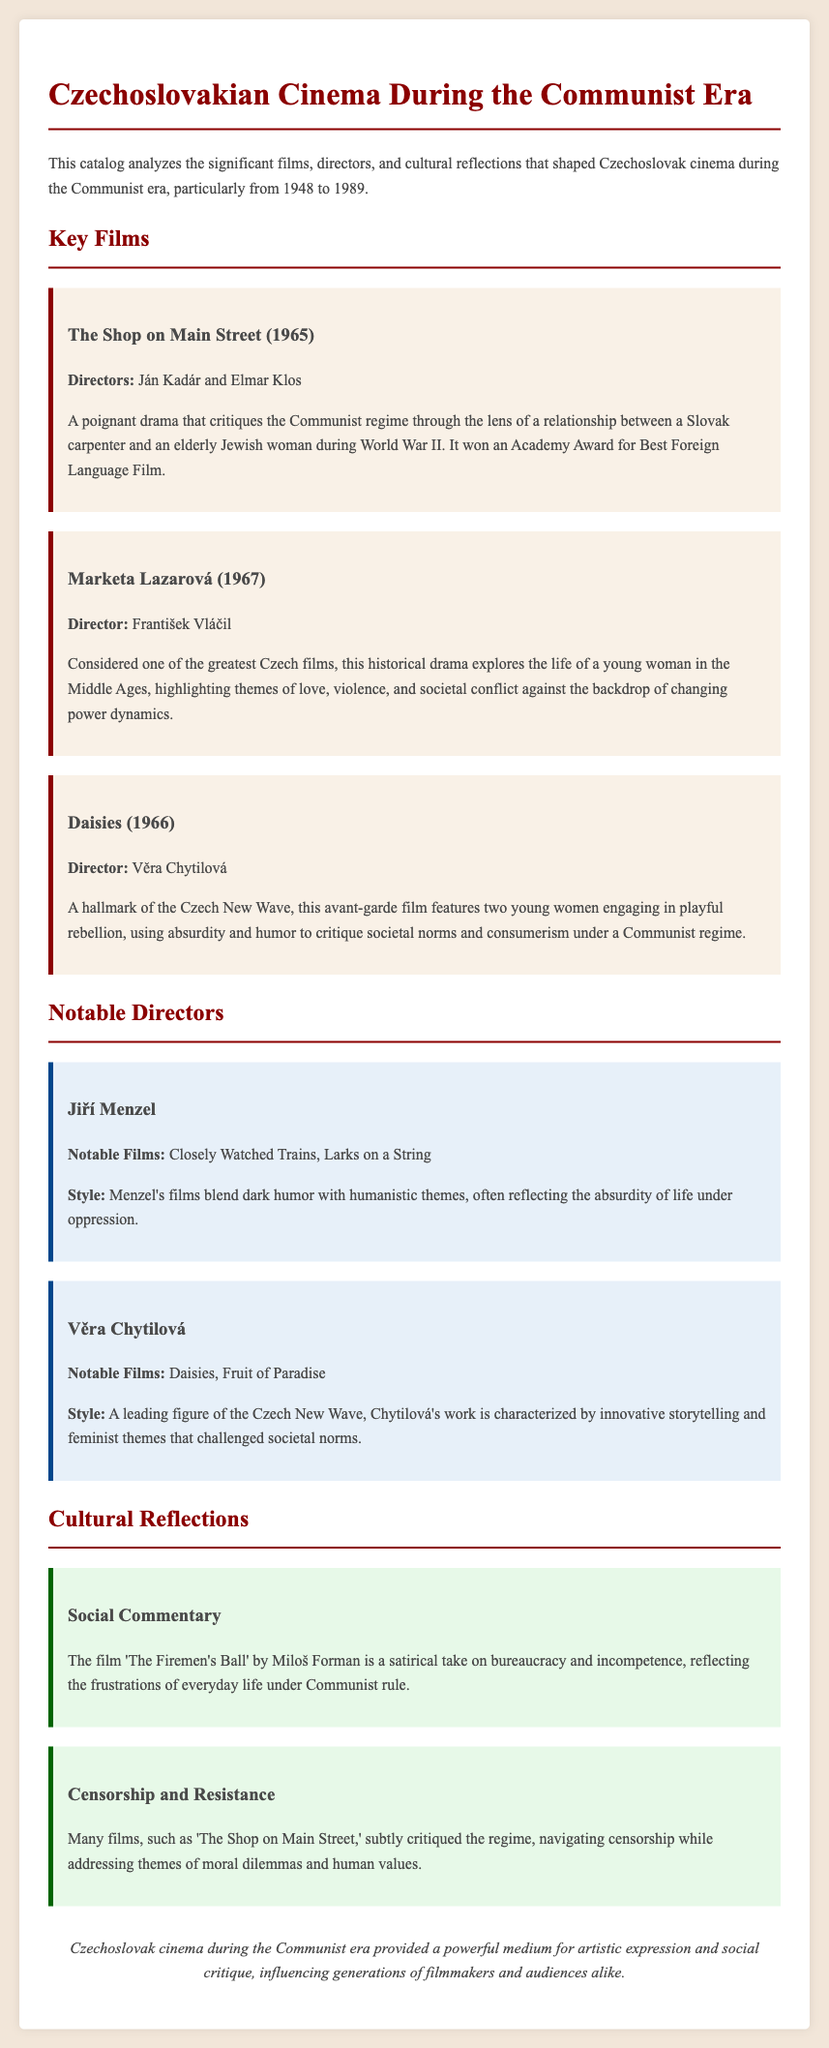What is the title of the film that won an Academy Award? The title mentioned is 'The Shop on Main Street,' which is noted for winning an Academy Award for Best Foreign Language Film.
Answer: The Shop on Main Street Who directed 'Marketa Lazarová'? The document states that 'Marketa Lazarová' was directed by František Vláčil.
Answer: František Vláčil What year was 'Daisies' released? The document indicates 'Daisies' was released in 1966.
Answer: 1966 Which director is known for blending dark humor with humanistic themes? Jiří Menzel is the director recognized for blending dark humor with humanistic themes in his films.
Answer: Jiří Menzel What major theme is explored in 'The Firemen's Ball'? The film 'The Firemen's Ball' critiques bureaucracy and incompetence, representing a major theme of social commentary.
Answer: Bureaucracy and incompetence Which film is associated with feminist themes and innovative storytelling? 'Daisies' is highlighted as a film associated with feminist themes and innovative storytelling.
Answer: Daisies What stylistic characteristic is attributed to Věra Chytilová’s films? Věra Chytilová's films are characterized by innovative storytelling and feminist themes that challenged societal norms.
Answer: Innovative storytelling and feminist themes How many films are mentioned under Notable Directors? The document references two films for each director under Notable Directors, totaling four notable films mentioned.
Answer: Four films What was a significant cultural reflection of Czechoslovak cinema during the Communist era? The cultural reflection includes critiques of the regime and social issues faced by people during the Communist era, as noted in several examples.
Answer: Critiques of the regime and social issues 